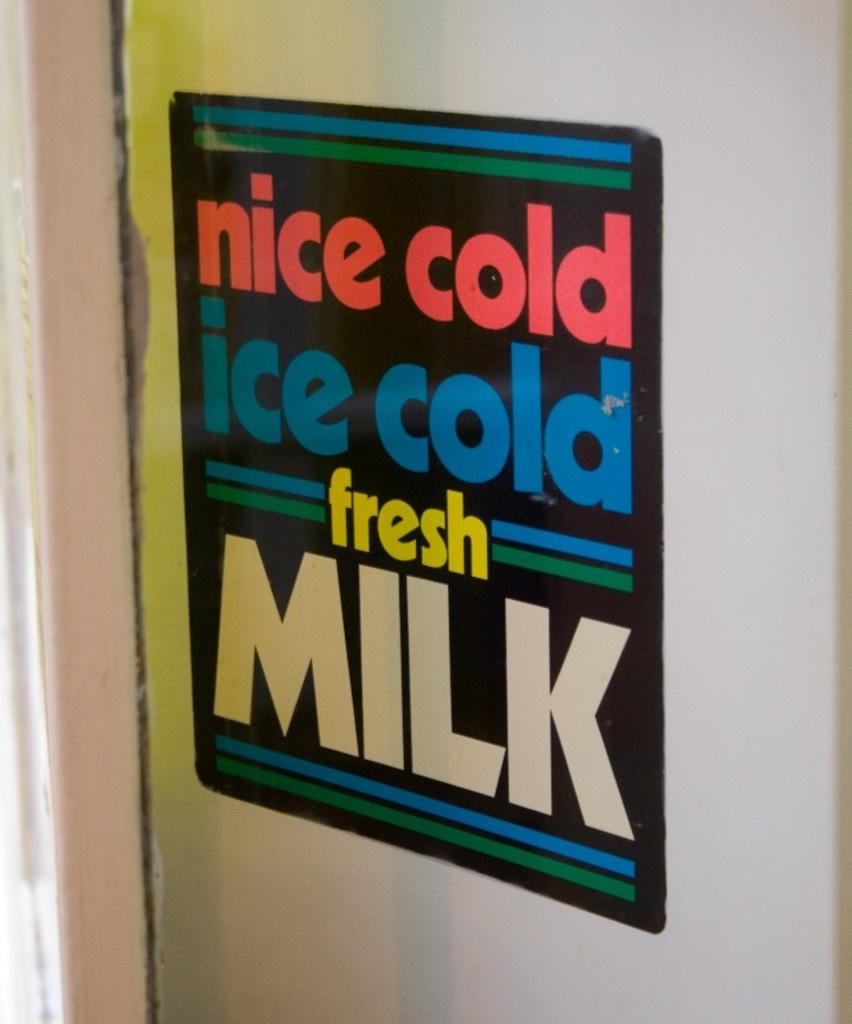<image>
Offer a succinct explanation of the picture presented. A sign that reads nice cold ice cold fresh milk. 